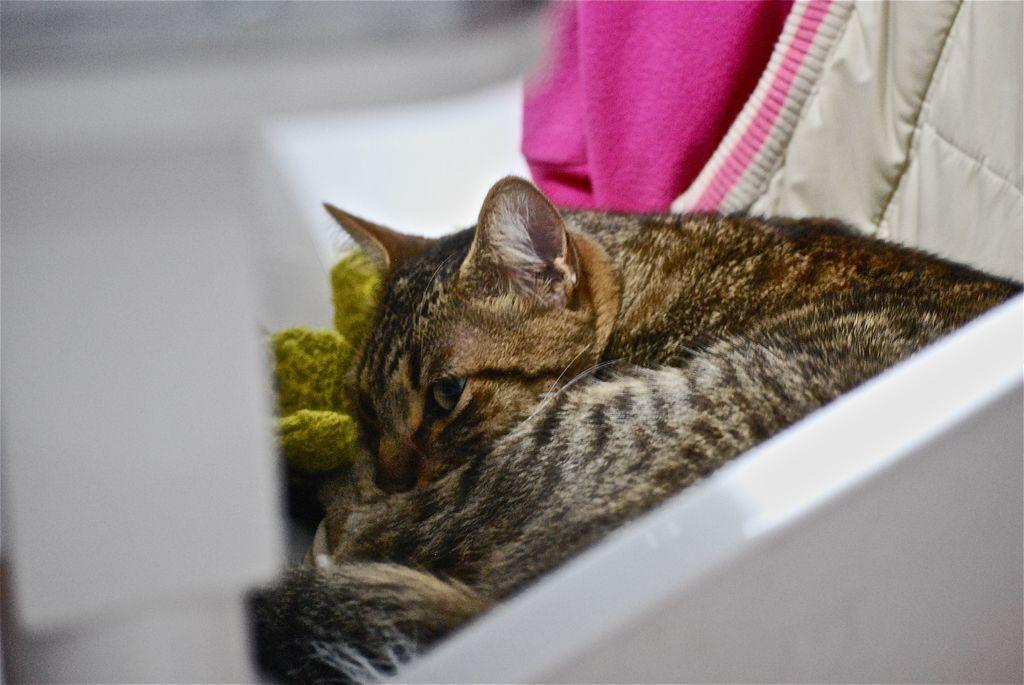What type of animal is in the image? There is a cat in the image. Where is the cat located? The cat is in a white object that looks like a box. What else can be seen near the cat? There are clothes near the cat. How would you describe the background of the image? The background of the image is blurred. How many icicles are hanging from the cat's whiskers in the image? There are no icicles present in the image, as it features a cat in a box with clothes nearby and a blurred background. 